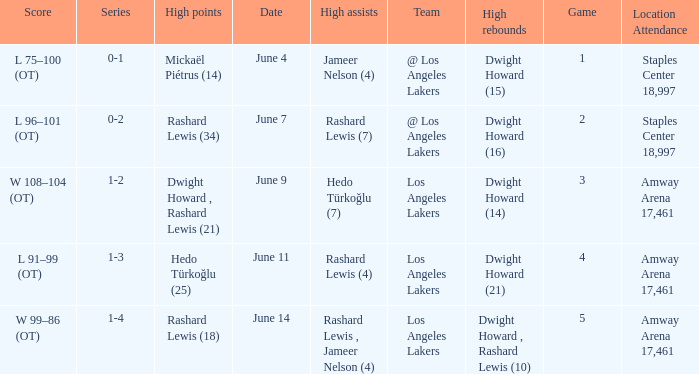What is the highest Game, when High Assists is "Hedo Türkoğlu (7)"? 3.0. 